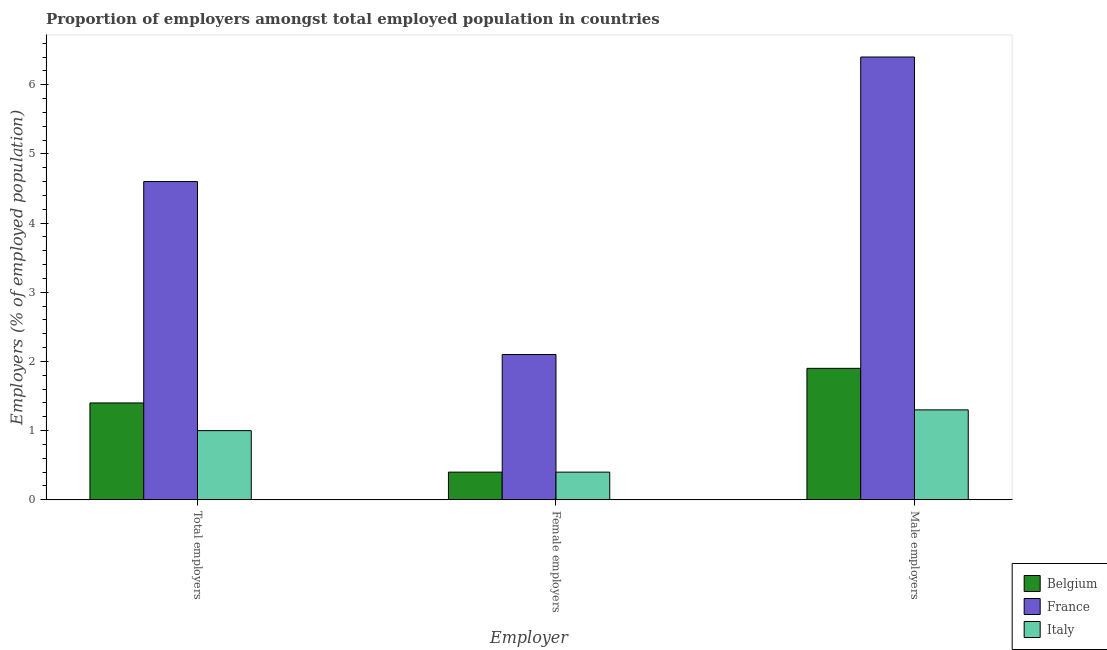How many groups of bars are there?
Make the answer very short. 3. Are the number of bars per tick equal to the number of legend labels?
Make the answer very short. Yes. How many bars are there on the 2nd tick from the left?
Provide a short and direct response. 3. How many bars are there on the 2nd tick from the right?
Your response must be concise. 3. What is the label of the 1st group of bars from the left?
Make the answer very short. Total employers. What is the percentage of female employers in Italy?
Provide a short and direct response. 0.4. Across all countries, what is the maximum percentage of total employers?
Your answer should be very brief. 4.6. Across all countries, what is the minimum percentage of female employers?
Your answer should be compact. 0.4. In which country was the percentage of total employers maximum?
Provide a succinct answer. France. What is the total percentage of male employers in the graph?
Your answer should be compact. 9.6. What is the difference between the percentage of total employers in Belgium and that in Italy?
Offer a terse response. 0.4. What is the difference between the percentage of male employers in Italy and the percentage of total employers in France?
Ensure brevity in your answer.  -3.3. What is the average percentage of total employers per country?
Your answer should be compact. 2.33. What is the difference between the percentage of male employers and percentage of female employers in France?
Ensure brevity in your answer.  4.3. What is the ratio of the percentage of total employers in France to that in Belgium?
Your answer should be very brief. 3.29. What is the difference between the highest and the second highest percentage of total employers?
Give a very brief answer. 3.2. What is the difference between the highest and the lowest percentage of female employers?
Provide a short and direct response. 1.7. In how many countries, is the percentage of total employers greater than the average percentage of total employers taken over all countries?
Your response must be concise. 1. Is it the case that in every country, the sum of the percentage of total employers and percentage of female employers is greater than the percentage of male employers?
Your response must be concise. No. How many bars are there?
Make the answer very short. 9. What is the difference between two consecutive major ticks on the Y-axis?
Give a very brief answer. 1. Does the graph contain any zero values?
Provide a succinct answer. No. What is the title of the graph?
Offer a terse response. Proportion of employers amongst total employed population in countries. What is the label or title of the X-axis?
Make the answer very short. Employer. What is the label or title of the Y-axis?
Your answer should be very brief. Employers (% of employed population). What is the Employers (% of employed population) of Belgium in Total employers?
Make the answer very short. 1.4. What is the Employers (% of employed population) of France in Total employers?
Provide a succinct answer. 4.6. What is the Employers (% of employed population) in Italy in Total employers?
Your answer should be compact. 1. What is the Employers (% of employed population) in Belgium in Female employers?
Ensure brevity in your answer.  0.4. What is the Employers (% of employed population) in France in Female employers?
Ensure brevity in your answer.  2.1. What is the Employers (% of employed population) in Italy in Female employers?
Keep it short and to the point. 0.4. What is the Employers (% of employed population) in Belgium in Male employers?
Your answer should be compact. 1.9. What is the Employers (% of employed population) in France in Male employers?
Offer a very short reply. 6.4. What is the Employers (% of employed population) in Italy in Male employers?
Your answer should be compact. 1.3. Across all Employer, what is the maximum Employers (% of employed population) of Belgium?
Provide a short and direct response. 1.9. Across all Employer, what is the maximum Employers (% of employed population) of France?
Give a very brief answer. 6.4. Across all Employer, what is the maximum Employers (% of employed population) in Italy?
Your answer should be compact. 1.3. Across all Employer, what is the minimum Employers (% of employed population) of Belgium?
Provide a short and direct response. 0.4. Across all Employer, what is the minimum Employers (% of employed population) in France?
Ensure brevity in your answer.  2.1. Across all Employer, what is the minimum Employers (% of employed population) in Italy?
Your response must be concise. 0.4. What is the total Employers (% of employed population) in Belgium in the graph?
Give a very brief answer. 3.7. What is the total Employers (% of employed population) of France in the graph?
Ensure brevity in your answer.  13.1. What is the difference between the Employers (% of employed population) in Belgium in Total employers and that in Female employers?
Keep it short and to the point. 1. What is the difference between the Employers (% of employed population) of France in Total employers and that in Female employers?
Offer a very short reply. 2.5. What is the difference between the Employers (% of employed population) of Italy in Total employers and that in Female employers?
Keep it short and to the point. 0.6. What is the difference between the Employers (% of employed population) of Belgium in Total employers and that in Male employers?
Provide a succinct answer. -0.5. What is the difference between the Employers (% of employed population) in Italy in Total employers and that in Male employers?
Your answer should be very brief. -0.3. What is the difference between the Employers (% of employed population) of France in Female employers and that in Male employers?
Your answer should be compact. -4.3. What is the difference between the Employers (% of employed population) in Belgium in Total employers and the Employers (% of employed population) in France in Female employers?
Offer a very short reply. -0.7. What is the difference between the Employers (% of employed population) of France in Total employers and the Employers (% of employed population) of Italy in Male employers?
Provide a short and direct response. 3.3. What is the difference between the Employers (% of employed population) of Belgium in Female employers and the Employers (% of employed population) of Italy in Male employers?
Keep it short and to the point. -0.9. What is the difference between the Employers (% of employed population) of France in Female employers and the Employers (% of employed population) of Italy in Male employers?
Offer a very short reply. 0.8. What is the average Employers (% of employed population) in Belgium per Employer?
Your answer should be compact. 1.23. What is the average Employers (% of employed population) of France per Employer?
Provide a short and direct response. 4.37. What is the average Employers (% of employed population) in Italy per Employer?
Your answer should be very brief. 0.9. What is the difference between the Employers (% of employed population) of Belgium and Employers (% of employed population) of France in Total employers?
Give a very brief answer. -3.2. What is the difference between the Employers (% of employed population) in Belgium and Employers (% of employed population) in Italy in Total employers?
Provide a short and direct response. 0.4. What is the difference between the Employers (% of employed population) in Belgium and Employers (% of employed population) in France in Female employers?
Keep it short and to the point. -1.7. What is the difference between the Employers (% of employed population) of Belgium and Employers (% of employed population) of France in Male employers?
Your response must be concise. -4.5. What is the ratio of the Employers (% of employed population) in Belgium in Total employers to that in Female employers?
Make the answer very short. 3.5. What is the ratio of the Employers (% of employed population) in France in Total employers to that in Female employers?
Give a very brief answer. 2.19. What is the ratio of the Employers (% of employed population) of Italy in Total employers to that in Female employers?
Keep it short and to the point. 2.5. What is the ratio of the Employers (% of employed population) in Belgium in Total employers to that in Male employers?
Provide a succinct answer. 0.74. What is the ratio of the Employers (% of employed population) of France in Total employers to that in Male employers?
Provide a short and direct response. 0.72. What is the ratio of the Employers (% of employed population) of Italy in Total employers to that in Male employers?
Provide a short and direct response. 0.77. What is the ratio of the Employers (% of employed population) in Belgium in Female employers to that in Male employers?
Provide a short and direct response. 0.21. What is the ratio of the Employers (% of employed population) of France in Female employers to that in Male employers?
Provide a succinct answer. 0.33. What is the ratio of the Employers (% of employed population) in Italy in Female employers to that in Male employers?
Your answer should be very brief. 0.31. What is the difference between the highest and the second highest Employers (% of employed population) of Belgium?
Make the answer very short. 0.5. What is the difference between the highest and the lowest Employers (% of employed population) in Belgium?
Offer a terse response. 1.5. What is the difference between the highest and the lowest Employers (% of employed population) of Italy?
Give a very brief answer. 0.9. 